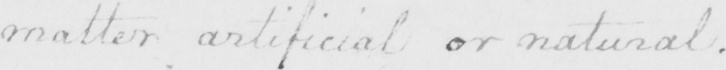What text is written in this handwritten line? matter artificial or natural . 